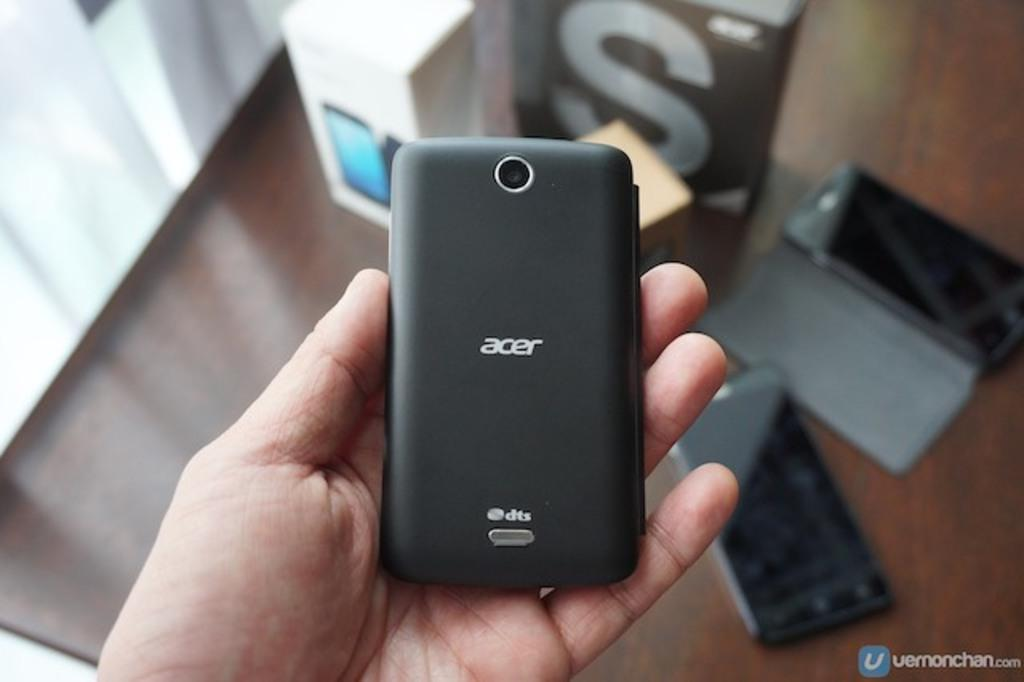<image>
Share a concise interpretation of the image provided. A person holding an acer phone with a broken phone below. 